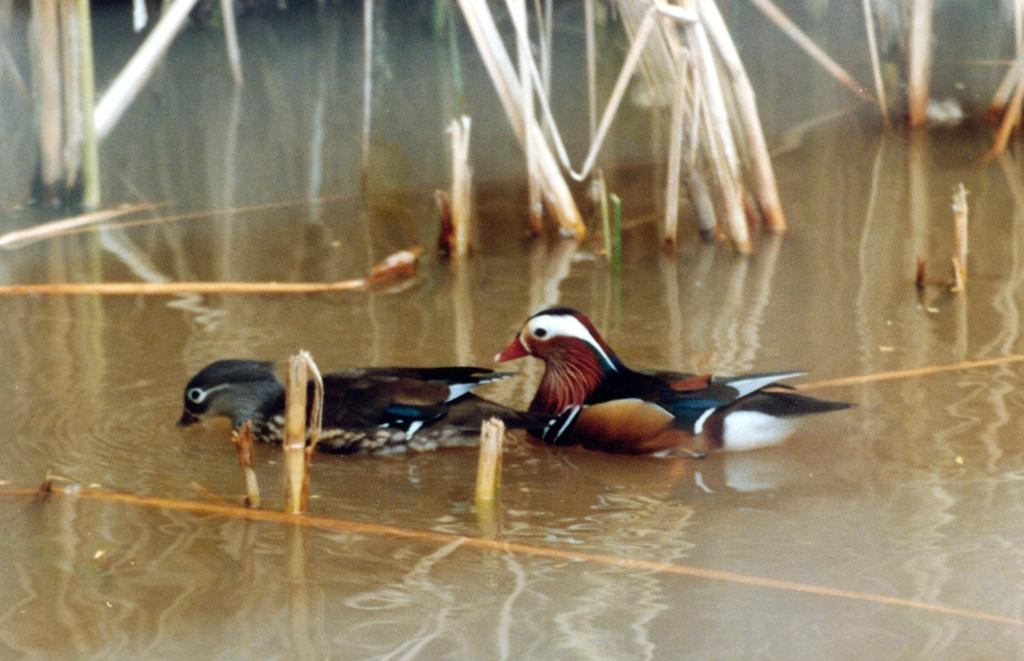What animals can be seen in the image? There are two birds on a water body in the image. What else is visible in the image besides the birds? There are plants visible in the image. Can you tell me the weight of the zoo in the image? There is no zoo present in the image, and therefore, it is not possible to determine its weight. 